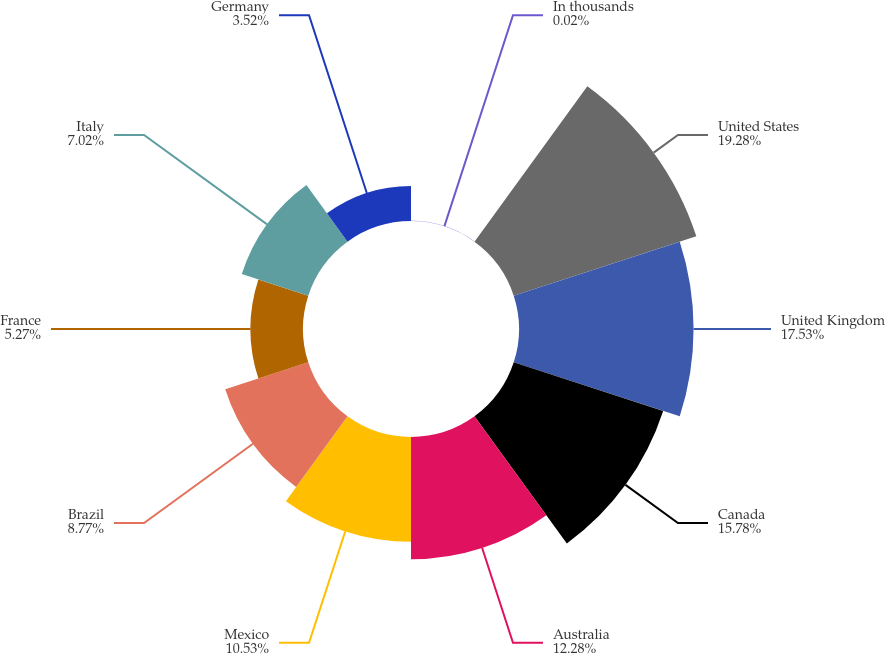<chart> <loc_0><loc_0><loc_500><loc_500><pie_chart><fcel>In thousands<fcel>United States<fcel>United Kingdom<fcel>Canada<fcel>Australia<fcel>Mexico<fcel>Brazil<fcel>France<fcel>Italy<fcel>Germany<nl><fcel>0.02%<fcel>19.28%<fcel>17.53%<fcel>15.78%<fcel>12.28%<fcel>10.53%<fcel>8.77%<fcel>5.27%<fcel>7.02%<fcel>3.52%<nl></chart> 